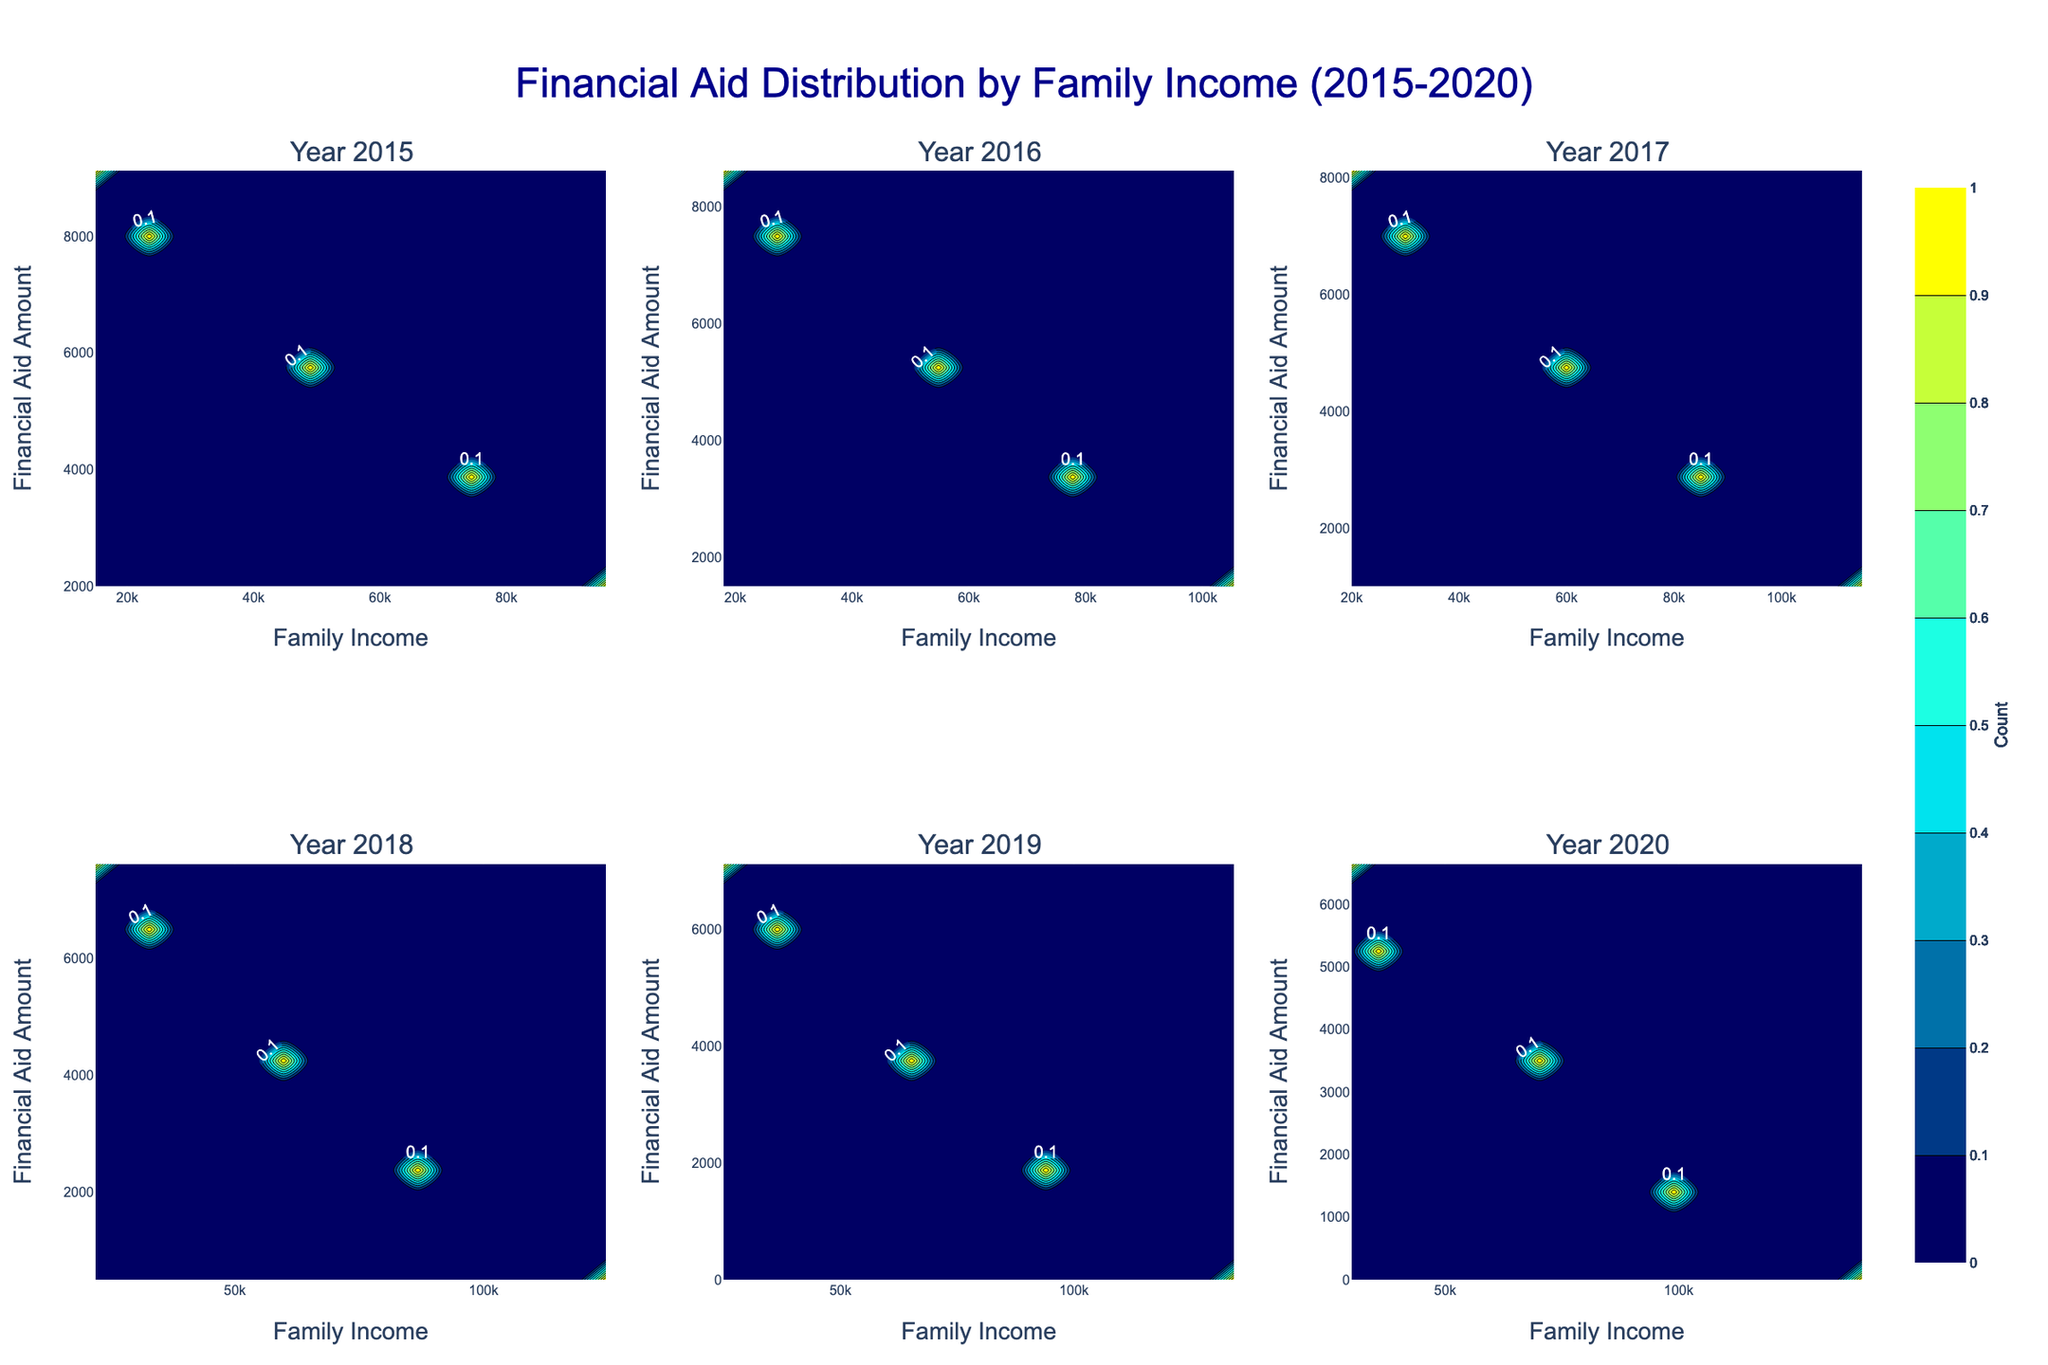What is the title of the entire figure? The title is usually displayed at the top of the figure. In this case, it reads "Financial Aid Distribution by Family Income (2015-2020)."
Answer: Financial Aid Distribution by Family Income (2015-2020) How many subplots are there in the figure? Count the number of individual plots within the entire figure. Each subplot corresponds to a year, and the figure is organized in a 2x3 grid for the years 2015 to 2020. This makes a total of 6 subplots.
Answer: 6 What does the color gradient on each contour subplot represent? The legend or colorbar indicates the meaning of the colors. In this figure, the color gradient represents the count of data points in each bin of the 2D histogram. Dark blue indicates low counts, transitioning through cyan to yellow for higher counts.
Answer: The count of data points Are the number of students eligible for financial aid increasing or decreasing over the years? By examining the contour plots, we can observe the density of data points. If the contours for higher financial aid amounts and lower family incomes are becoming denser over time, the number of eligible students is likely increasing.
Answer: Increasing In which year is the distribution of financial aid most concentrated around low family incomes? Compare the density of the contours across all subplots. The year with the highest density of contours concentrated in the lower family income range indicates this. Eyeballing the plots, 2015 has the highest density around low family incomes.
Answer: 2015 Which year shows the least financial aid provided to students from high-income families? Look at the upper end of the family income scale (higher x-axis values) for each subplot. Determine which year has the fewest or smallest contour lines in that region. 2015 and 2016 seem to have fewer contours in the high-income sections.
Answer: 2015 and 2016 In which year is the highest financial aid amount distributed, regardless of family income? Check the y-axis (Financial Aid) for each subplot to see where the highest values are reached. The contours reaching the highest point on the y-axis will indicate the year. In 2015, the maximum financial aid seems to be distributed up to 9500.
Answer: 2015 How does the distribution of financial aid change from 2015 to 2020? Observe the trends in the distribution and density of contours over the six years. High aid amounts shift from lower income families in 2015 to slightly higher income families by 2020, with generally decreasing aid amounts for high-income families.
Answer: Shift towards higher income families with decreasing aid amounts In which year does the contour plot show the widest range of family incomes receiving financial aid? Find the subplot where the contours span the broadest range on the x-axis. For instance, which plot shows contours extending from low-income to high-income families more extensively? 2020 seems to cover a wider range of income.
Answer: 2020 